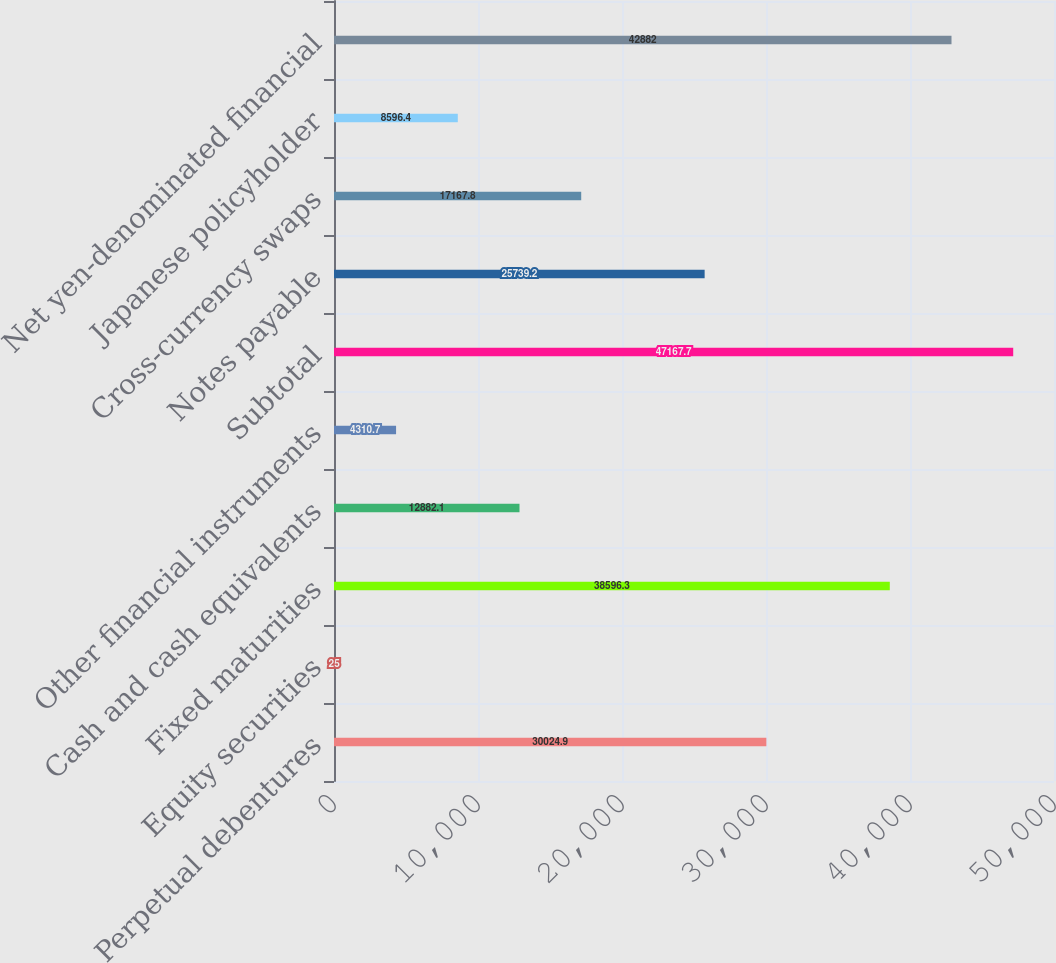Convert chart to OTSL. <chart><loc_0><loc_0><loc_500><loc_500><bar_chart><fcel>Perpetual debentures<fcel>Equity securities<fcel>Fixed maturities<fcel>Cash and cash equivalents<fcel>Other financial instruments<fcel>Subtotal<fcel>Notes payable<fcel>Cross-currency swaps<fcel>Japanese policyholder<fcel>Net yen-denominated financial<nl><fcel>30024.9<fcel>25<fcel>38596.3<fcel>12882.1<fcel>4310.7<fcel>47167.7<fcel>25739.2<fcel>17167.8<fcel>8596.4<fcel>42882<nl></chart> 